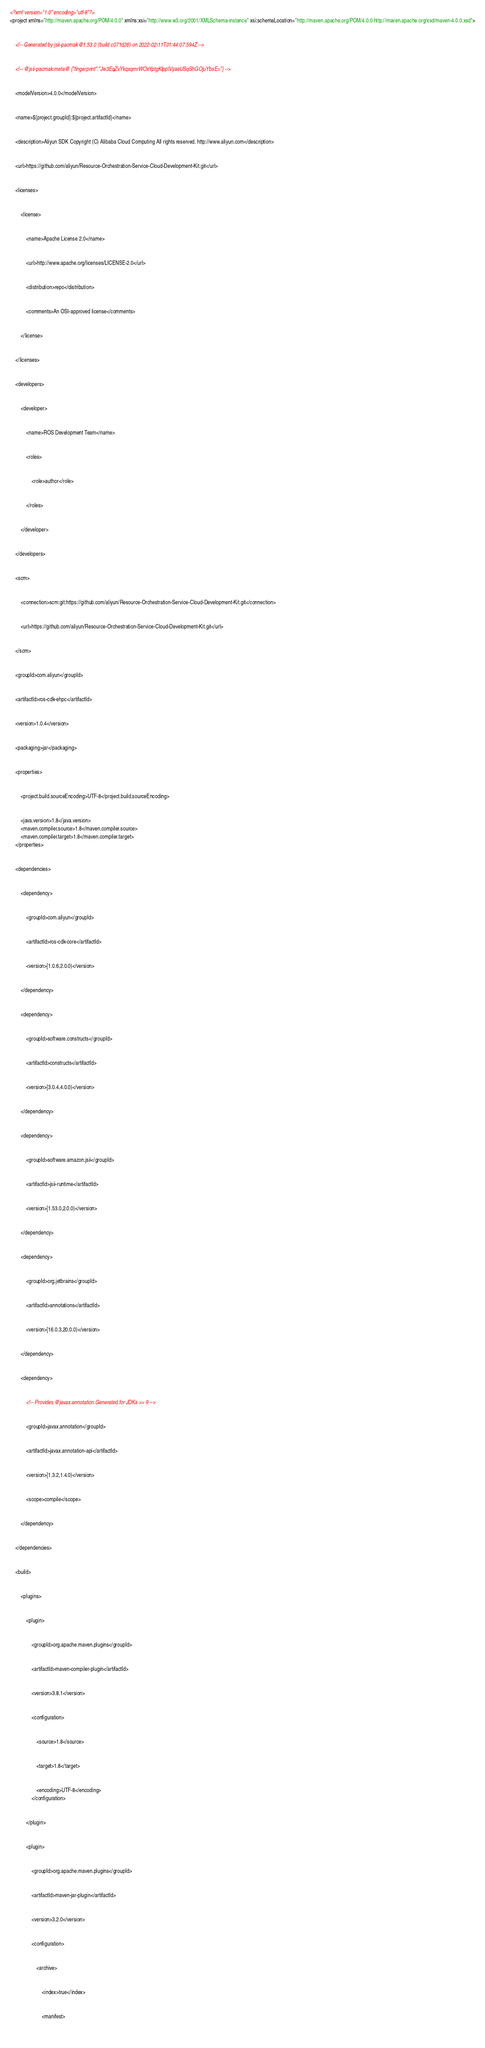<code> <loc_0><loc_0><loc_500><loc_500><_XML_><?xml version="1.0" encoding="utf-8"?>
<project xmlns="http://maven.apache.org/POM/4.0.0" xmlns:xsi="http://www.w3.org/2001/XMLSchema-instance" xsi:schemaLocation="http://maven.apache.org/POM/4.0.0 http://maven.apache.org/xsd/maven-4.0.0.xsd">
	
  
	<!-- Generated by jsii-pacmak@1.53.0 (build c071d26) on 2022-02-11T01:44:07.594Z -->
	
  
	<!-- @jsii-pacmak:meta@ {"fingerprint":"Jw3EqZvYkqxqmrWOxYptgKlppIVyaeUSqShGOjuYbsE="} -->
	
  
	<modelVersion>4.0.0</modelVersion>
	
  
	<name>${project.groupId}:${project.artifactId}</name>
	
  
	<description>Aliyun SDK Copyright (C) Alibaba Cloud Computing All rights reserved. http://www.aliyun.com</description>
	
  
	<url>https://github.com/aliyun/Resource-Orchestration-Service-Cloud-Development-Kit.git</url>
	
  
	<licenses>
		
    
		<license>
			
      
			<name>Apache License 2.0</name>
			
      
			<url>http://www.apache.org/licenses/LICENSE-2.0</url>
			
      
			<distribution>repo</distribution>
			
      
			<comments>An OSI-approved license</comments>
			
    
		</license>
		
  
	</licenses>
	
  
	<developers>
		
    
		<developer>
			
      
			<name>ROS Development Team</name>
			
      
			<roles>
				
        
				<role>author</role>
				
      
			</roles>
			
    
		</developer>
		
  
	</developers>
	
  
	<scm>
		
    
		<connection>scm:git:https://github.com/aliyun/Resource-Orchestration-Service-Cloud-Development-Kit.git</connection>
		
    
		<url>https://github.com/aliyun/Resource-Orchestration-Service-Cloud-Development-Kit.git</url>
		
  
	</scm>
	
  
	<groupId>com.aliyun</groupId>
	
  
	<artifactId>ros-cdk-ehpc</artifactId>
	
  
	<version>1.0.4</version>
	
  
	<packaging>jar</packaging>
	
  
	<properties>
		
    
		<project.build.sourceEncoding>UTF-8</project.build.sourceEncoding>
		
  
		<java.version>1.8</java.version>
		<maven.compiler.source>1.8</maven.compiler.source>
		<maven.compiler.target>1.8</maven.compiler.target>
	</properties>
	
  
	<dependencies>
		
    
		<dependency>
			
      
			<groupId>com.aliyun</groupId>
			
      
			<artifactId>ros-cdk-core</artifactId>
			
      
			<version>[1.0.6,2.0.0)</version>
			
    
		</dependency>
		
    
		<dependency>
			
      
			<groupId>software.constructs</groupId>
			
      
			<artifactId>constructs</artifactId>
			
      
			<version>[3.0.4,4.0.0)</version>
			
    
		</dependency>
		
    
		<dependency>
			
      
			<groupId>software.amazon.jsii</groupId>
			
      
			<artifactId>jsii-runtime</artifactId>
			
      
			<version>[1.53.0,2.0.0)</version>
			
    
		</dependency>
		
    
		<dependency>
			
      
			<groupId>org.jetbrains</groupId>
			
      
			<artifactId>annotations</artifactId>
			
      
			<version>[16.0.3,20.0.0)</version>
			
    
		</dependency>
		
    
		<dependency>
			
      
			<!-- Provides @javax.annotation.Generated for JDKs >= 9 -->
			
      
			<groupId>javax.annotation</groupId>
			
      
			<artifactId>javax.annotation-api</artifactId>
			
      
			<version>[1.3.2,1.4.0)</version>
			
      
			<scope>compile</scope>
			
    
		</dependency>
		
  
	</dependencies>
	
  
	<build>
		
    
		<plugins>
			
      
			<plugin>
				
        
				<groupId>org.apache.maven.plugins</groupId>
				
        
				<artifactId>maven-compiler-plugin</artifactId>
				
        
				<version>3.8.1</version>
				
        
				<configuration>
					
          
					<source>1.8</source>
					
          
					<target>1.8</target>
					
        
					<encoding>UTF-8</encoding>
				</configuration>
				
      
			</plugin>
			
      
			<plugin>
				
        
				<groupId>org.apache.maven.plugins</groupId>
				
        
				<artifactId>maven-jar-plugin</artifactId>
				
        
				<version>3.2.0</version>
				
        
				<configuration>
					
          
					<archive>
						
            
						<index>true</index>
						
            
						<manifest>
							
              </code> 